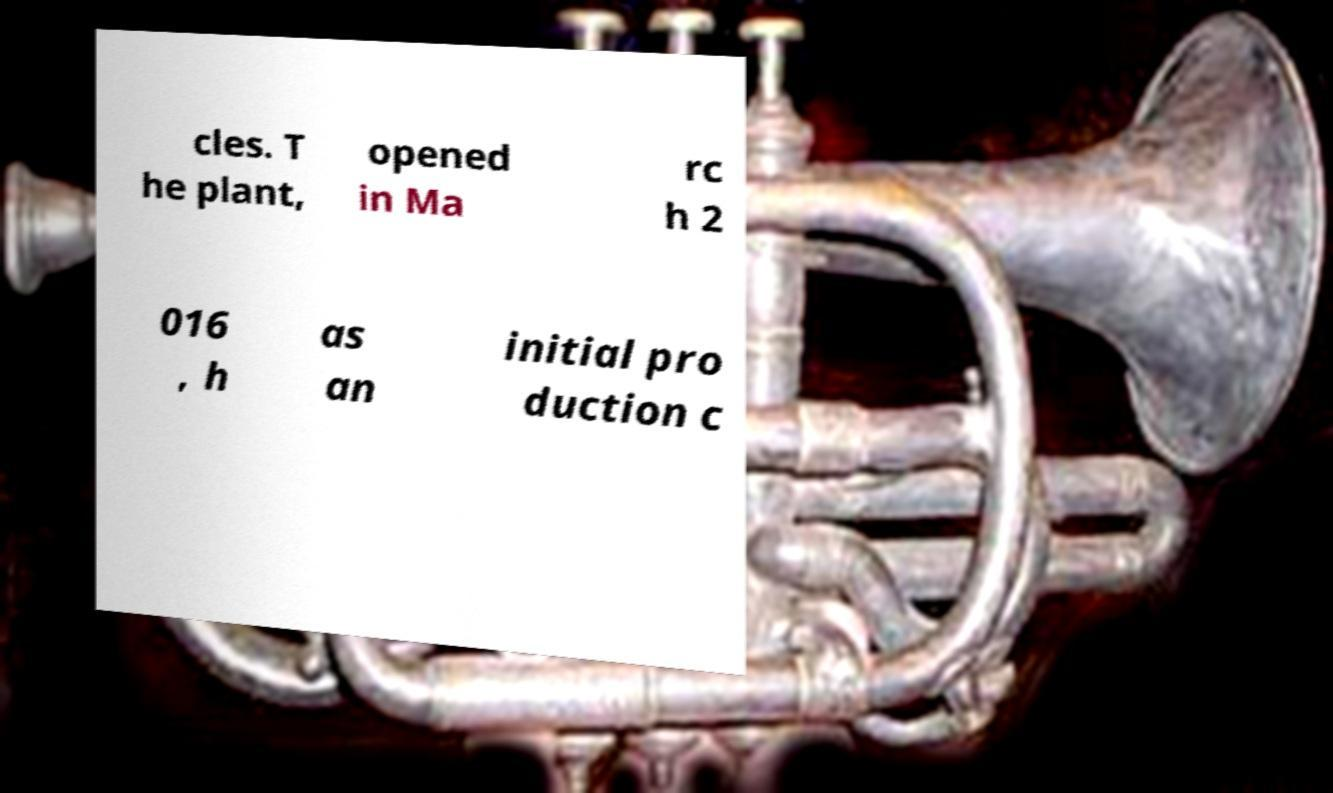What messages or text are displayed in this image? I need them in a readable, typed format. cles. T he plant, opened in Ma rc h 2 016 , h as an initial pro duction c 